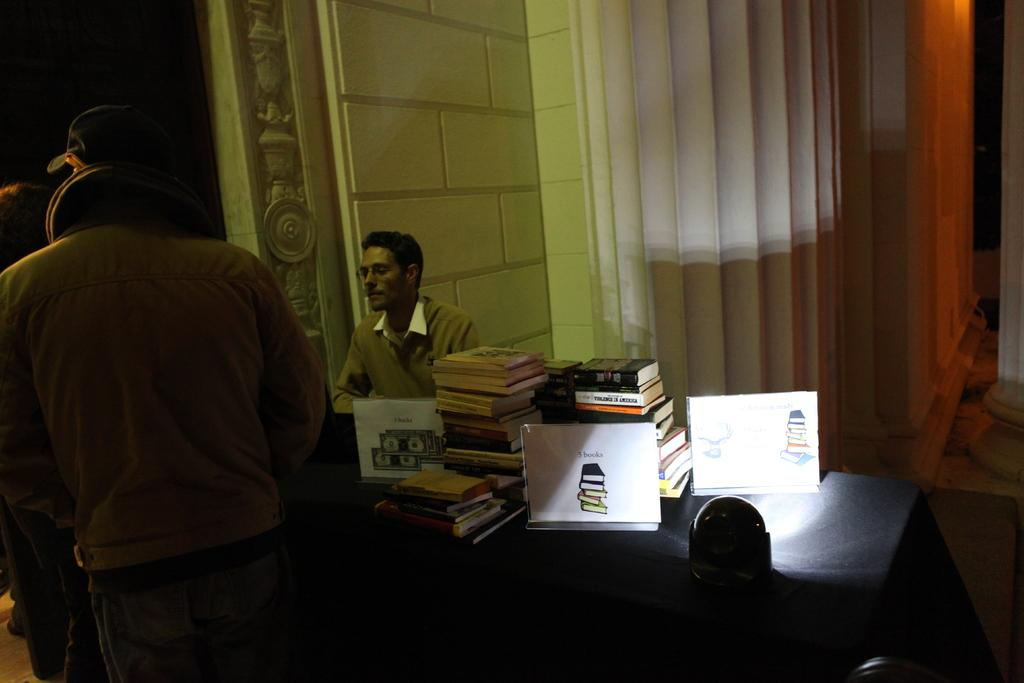What is the primary subject of the image? There is a person standing in the image. What object is present in the image alongside the person? There is a table in the image. What items can be seen on the table? There are books on the table. Can you describe the position of the second person in the image? There is another person sitting behind the table. What type of disgust can be seen on the mom's face in the image? There is no mom present in the image, and therefore no facial expression to describe. 